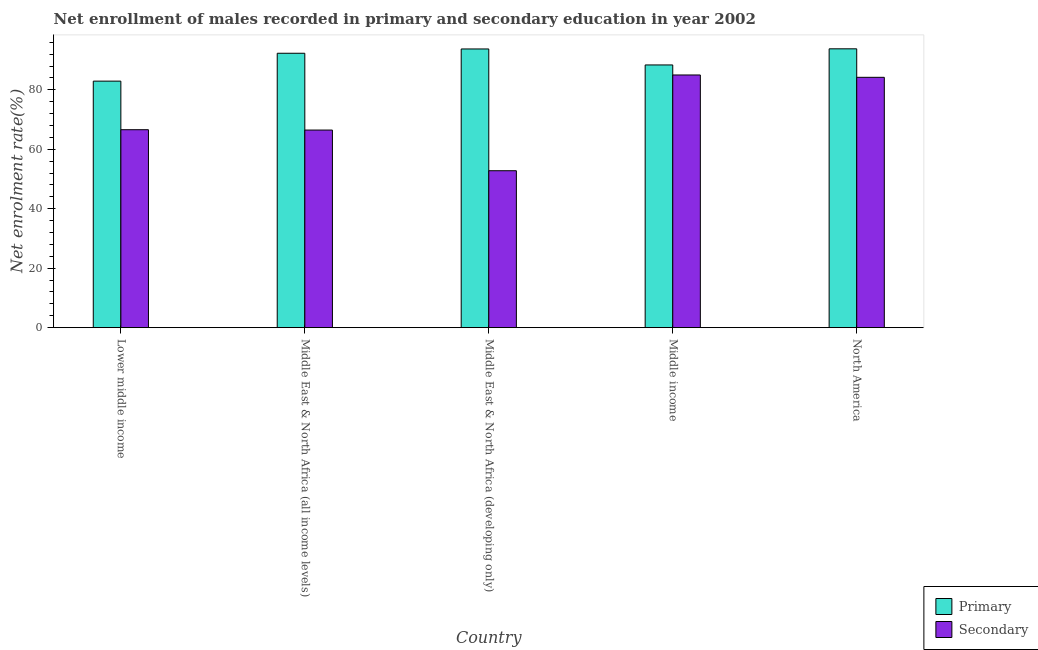How many different coloured bars are there?
Offer a terse response. 2. Are the number of bars per tick equal to the number of legend labels?
Give a very brief answer. Yes. Are the number of bars on each tick of the X-axis equal?
Your answer should be compact. Yes. How many bars are there on the 3rd tick from the left?
Provide a succinct answer. 2. How many bars are there on the 4th tick from the right?
Your answer should be very brief. 2. What is the label of the 3rd group of bars from the left?
Provide a short and direct response. Middle East & North Africa (developing only). In how many cases, is the number of bars for a given country not equal to the number of legend labels?
Keep it short and to the point. 0. What is the enrollment rate in secondary education in Middle East & North Africa (developing only)?
Your answer should be compact. 52.8. Across all countries, what is the maximum enrollment rate in primary education?
Offer a terse response. 93.82. Across all countries, what is the minimum enrollment rate in primary education?
Your answer should be compact. 82.95. In which country was the enrollment rate in secondary education maximum?
Offer a very short reply. Middle income. In which country was the enrollment rate in secondary education minimum?
Offer a very short reply. Middle East & North Africa (developing only). What is the total enrollment rate in secondary education in the graph?
Ensure brevity in your answer.  355.13. What is the difference between the enrollment rate in secondary education in Middle East & North Africa (all income levels) and that in Middle East & North Africa (developing only)?
Your answer should be very brief. 13.69. What is the difference between the enrollment rate in secondary education in Middle East & North Africa (developing only) and the enrollment rate in primary education in Middle East & North Africa (all income levels)?
Your response must be concise. -39.53. What is the average enrollment rate in primary education per country?
Ensure brevity in your answer.  90.25. What is the difference between the enrollment rate in secondary education and enrollment rate in primary education in Middle income?
Ensure brevity in your answer.  -3.37. What is the ratio of the enrollment rate in primary education in Middle East & North Africa (all income levels) to that in Middle East & North Africa (developing only)?
Make the answer very short. 0.98. Is the enrollment rate in secondary education in Lower middle income less than that in Middle East & North Africa (all income levels)?
Offer a terse response. No. Is the difference between the enrollment rate in primary education in Middle East & North Africa (all income levels) and Middle East & North Africa (developing only) greater than the difference between the enrollment rate in secondary education in Middle East & North Africa (all income levels) and Middle East & North Africa (developing only)?
Your answer should be very brief. No. What is the difference between the highest and the second highest enrollment rate in secondary education?
Provide a succinct answer. 0.79. What is the difference between the highest and the lowest enrollment rate in primary education?
Provide a short and direct response. 10.87. In how many countries, is the enrollment rate in secondary education greater than the average enrollment rate in secondary education taken over all countries?
Ensure brevity in your answer.  2. What does the 2nd bar from the left in Middle East & North Africa (all income levels) represents?
Your answer should be compact. Secondary. What does the 2nd bar from the right in Middle East & North Africa (all income levels) represents?
Provide a short and direct response. Primary. How many bars are there?
Your answer should be compact. 10. Are all the bars in the graph horizontal?
Offer a very short reply. No. How many countries are there in the graph?
Your answer should be compact. 5. What is the difference between two consecutive major ticks on the Y-axis?
Provide a succinct answer. 20. Does the graph contain any zero values?
Your answer should be compact. No. What is the title of the graph?
Your response must be concise. Net enrollment of males recorded in primary and secondary education in year 2002. Does "Largest city" appear as one of the legend labels in the graph?
Offer a terse response. No. What is the label or title of the X-axis?
Provide a succinct answer. Country. What is the label or title of the Y-axis?
Offer a very short reply. Net enrolment rate(%). What is the Net enrolment rate(%) of Primary in Lower middle income?
Offer a very short reply. 82.95. What is the Net enrolment rate(%) in Secondary in Lower middle income?
Keep it short and to the point. 66.6. What is the Net enrolment rate(%) in Primary in Middle East & North Africa (all income levels)?
Make the answer very short. 92.33. What is the Net enrolment rate(%) of Secondary in Middle East & North Africa (all income levels)?
Make the answer very short. 66.48. What is the Net enrolment rate(%) of Primary in Middle East & North Africa (developing only)?
Give a very brief answer. 93.77. What is the Net enrolment rate(%) of Secondary in Middle East & North Africa (developing only)?
Offer a terse response. 52.8. What is the Net enrolment rate(%) of Primary in Middle income?
Offer a terse response. 88.39. What is the Net enrolment rate(%) of Secondary in Middle income?
Your answer should be very brief. 85.02. What is the Net enrolment rate(%) in Primary in North America?
Ensure brevity in your answer.  93.82. What is the Net enrolment rate(%) of Secondary in North America?
Your answer should be very brief. 84.23. Across all countries, what is the maximum Net enrolment rate(%) of Primary?
Your answer should be very brief. 93.82. Across all countries, what is the maximum Net enrolment rate(%) in Secondary?
Offer a very short reply. 85.02. Across all countries, what is the minimum Net enrolment rate(%) in Primary?
Your response must be concise. 82.95. Across all countries, what is the minimum Net enrolment rate(%) in Secondary?
Ensure brevity in your answer.  52.8. What is the total Net enrolment rate(%) in Primary in the graph?
Keep it short and to the point. 451.25. What is the total Net enrolment rate(%) of Secondary in the graph?
Your answer should be compact. 355.13. What is the difference between the Net enrolment rate(%) of Primary in Lower middle income and that in Middle East & North Africa (all income levels)?
Give a very brief answer. -9.38. What is the difference between the Net enrolment rate(%) of Secondary in Lower middle income and that in Middle East & North Africa (all income levels)?
Offer a terse response. 0.12. What is the difference between the Net enrolment rate(%) in Primary in Lower middle income and that in Middle East & North Africa (developing only)?
Keep it short and to the point. -10.82. What is the difference between the Net enrolment rate(%) of Secondary in Lower middle income and that in Middle East & North Africa (developing only)?
Ensure brevity in your answer.  13.8. What is the difference between the Net enrolment rate(%) of Primary in Lower middle income and that in Middle income?
Make the answer very short. -5.44. What is the difference between the Net enrolment rate(%) in Secondary in Lower middle income and that in Middle income?
Your answer should be very brief. -18.42. What is the difference between the Net enrolment rate(%) in Primary in Lower middle income and that in North America?
Keep it short and to the point. -10.87. What is the difference between the Net enrolment rate(%) in Secondary in Lower middle income and that in North America?
Offer a terse response. -17.62. What is the difference between the Net enrolment rate(%) in Primary in Middle East & North Africa (all income levels) and that in Middle East & North Africa (developing only)?
Give a very brief answer. -1.44. What is the difference between the Net enrolment rate(%) in Secondary in Middle East & North Africa (all income levels) and that in Middle East & North Africa (developing only)?
Provide a succinct answer. 13.69. What is the difference between the Net enrolment rate(%) of Primary in Middle East & North Africa (all income levels) and that in Middle income?
Your response must be concise. 3.94. What is the difference between the Net enrolment rate(%) in Secondary in Middle East & North Africa (all income levels) and that in Middle income?
Provide a short and direct response. -18.53. What is the difference between the Net enrolment rate(%) of Primary in Middle East & North Africa (all income levels) and that in North America?
Make the answer very short. -1.49. What is the difference between the Net enrolment rate(%) of Secondary in Middle East & North Africa (all income levels) and that in North America?
Provide a short and direct response. -17.74. What is the difference between the Net enrolment rate(%) of Primary in Middle East & North Africa (developing only) and that in Middle income?
Offer a very short reply. 5.38. What is the difference between the Net enrolment rate(%) of Secondary in Middle East & North Africa (developing only) and that in Middle income?
Offer a terse response. -32.22. What is the difference between the Net enrolment rate(%) in Primary in Middle East & North Africa (developing only) and that in North America?
Provide a short and direct response. -0.05. What is the difference between the Net enrolment rate(%) of Secondary in Middle East & North Africa (developing only) and that in North America?
Ensure brevity in your answer.  -31.43. What is the difference between the Net enrolment rate(%) of Primary in Middle income and that in North America?
Your response must be concise. -5.43. What is the difference between the Net enrolment rate(%) of Secondary in Middle income and that in North America?
Ensure brevity in your answer.  0.79. What is the difference between the Net enrolment rate(%) in Primary in Lower middle income and the Net enrolment rate(%) in Secondary in Middle East & North Africa (all income levels)?
Make the answer very short. 16.46. What is the difference between the Net enrolment rate(%) of Primary in Lower middle income and the Net enrolment rate(%) of Secondary in Middle East & North Africa (developing only)?
Give a very brief answer. 30.15. What is the difference between the Net enrolment rate(%) of Primary in Lower middle income and the Net enrolment rate(%) of Secondary in Middle income?
Keep it short and to the point. -2.07. What is the difference between the Net enrolment rate(%) in Primary in Lower middle income and the Net enrolment rate(%) in Secondary in North America?
Ensure brevity in your answer.  -1.28. What is the difference between the Net enrolment rate(%) in Primary in Middle East & North Africa (all income levels) and the Net enrolment rate(%) in Secondary in Middle East & North Africa (developing only)?
Offer a very short reply. 39.53. What is the difference between the Net enrolment rate(%) in Primary in Middle East & North Africa (all income levels) and the Net enrolment rate(%) in Secondary in Middle income?
Your response must be concise. 7.31. What is the difference between the Net enrolment rate(%) in Primary in Middle East & North Africa (all income levels) and the Net enrolment rate(%) in Secondary in North America?
Your response must be concise. 8.1. What is the difference between the Net enrolment rate(%) in Primary in Middle East & North Africa (developing only) and the Net enrolment rate(%) in Secondary in Middle income?
Make the answer very short. 8.75. What is the difference between the Net enrolment rate(%) in Primary in Middle East & North Africa (developing only) and the Net enrolment rate(%) in Secondary in North America?
Your answer should be compact. 9.54. What is the difference between the Net enrolment rate(%) in Primary in Middle income and the Net enrolment rate(%) in Secondary in North America?
Provide a short and direct response. 4.16. What is the average Net enrolment rate(%) of Primary per country?
Keep it short and to the point. 90.25. What is the average Net enrolment rate(%) in Secondary per country?
Provide a short and direct response. 71.03. What is the difference between the Net enrolment rate(%) of Primary and Net enrolment rate(%) of Secondary in Lower middle income?
Your response must be concise. 16.34. What is the difference between the Net enrolment rate(%) of Primary and Net enrolment rate(%) of Secondary in Middle East & North Africa (all income levels)?
Offer a terse response. 25.84. What is the difference between the Net enrolment rate(%) of Primary and Net enrolment rate(%) of Secondary in Middle East & North Africa (developing only)?
Keep it short and to the point. 40.97. What is the difference between the Net enrolment rate(%) of Primary and Net enrolment rate(%) of Secondary in Middle income?
Keep it short and to the point. 3.37. What is the difference between the Net enrolment rate(%) in Primary and Net enrolment rate(%) in Secondary in North America?
Offer a very short reply. 9.59. What is the ratio of the Net enrolment rate(%) of Primary in Lower middle income to that in Middle East & North Africa (all income levels)?
Make the answer very short. 0.9. What is the ratio of the Net enrolment rate(%) of Secondary in Lower middle income to that in Middle East & North Africa (all income levels)?
Ensure brevity in your answer.  1. What is the ratio of the Net enrolment rate(%) in Primary in Lower middle income to that in Middle East & North Africa (developing only)?
Provide a succinct answer. 0.88. What is the ratio of the Net enrolment rate(%) of Secondary in Lower middle income to that in Middle East & North Africa (developing only)?
Make the answer very short. 1.26. What is the ratio of the Net enrolment rate(%) in Primary in Lower middle income to that in Middle income?
Your answer should be very brief. 0.94. What is the ratio of the Net enrolment rate(%) in Secondary in Lower middle income to that in Middle income?
Ensure brevity in your answer.  0.78. What is the ratio of the Net enrolment rate(%) in Primary in Lower middle income to that in North America?
Provide a short and direct response. 0.88. What is the ratio of the Net enrolment rate(%) of Secondary in Lower middle income to that in North America?
Your answer should be very brief. 0.79. What is the ratio of the Net enrolment rate(%) of Primary in Middle East & North Africa (all income levels) to that in Middle East & North Africa (developing only)?
Your response must be concise. 0.98. What is the ratio of the Net enrolment rate(%) of Secondary in Middle East & North Africa (all income levels) to that in Middle East & North Africa (developing only)?
Give a very brief answer. 1.26. What is the ratio of the Net enrolment rate(%) of Primary in Middle East & North Africa (all income levels) to that in Middle income?
Your answer should be compact. 1.04. What is the ratio of the Net enrolment rate(%) in Secondary in Middle East & North Africa (all income levels) to that in Middle income?
Give a very brief answer. 0.78. What is the ratio of the Net enrolment rate(%) of Primary in Middle East & North Africa (all income levels) to that in North America?
Make the answer very short. 0.98. What is the ratio of the Net enrolment rate(%) in Secondary in Middle East & North Africa (all income levels) to that in North America?
Make the answer very short. 0.79. What is the ratio of the Net enrolment rate(%) in Primary in Middle East & North Africa (developing only) to that in Middle income?
Your answer should be compact. 1.06. What is the ratio of the Net enrolment rate(%) in Secondary in Middle East & North Africa (developing only) to that in Middle income?
Give a very brief answer. 0.62. What is the ratio of the Net enrolment rate(%) of Secondary in Middle East & North Africa (developing only) to that in North America?
Keep it short and to the point. 0.63. What is the ratio of the Net enrolment rate(%) in Primary in Middle income to that in North America?
Offer a terse response. 0.94. What is the ratio of the Net enrolment rate(%) of Secondary in Middle income to that in North America?
Offer a very short reply. 1.01. What is the difference between the highest and the second highest Net enrolment rate(%) of Primary?
Your answer should be compact. 0.05. What is the difference between the highest and the second highest Net enrolment rate(%) of Secondary?
Give a very brief answer. 0.79. What is the difference between the highest and the lowest Net enrolment rate(%) in Primary?
Provide a succinct answer. 10.87. What is the difference between the highest and the lowest Net enrolment rate(%) of Secondary?
Offer a very short reply. 32.22. 